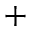Convert formula to latex. <formula><loc_0><loc_0><loc_500><loc_500>^ { + }</formula> 